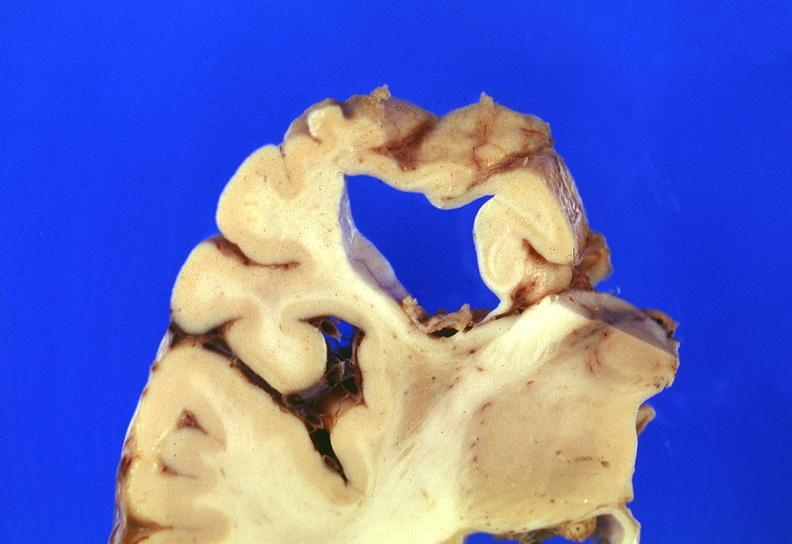s nervous present?
Answer the question using a single word or phrase. Yes 